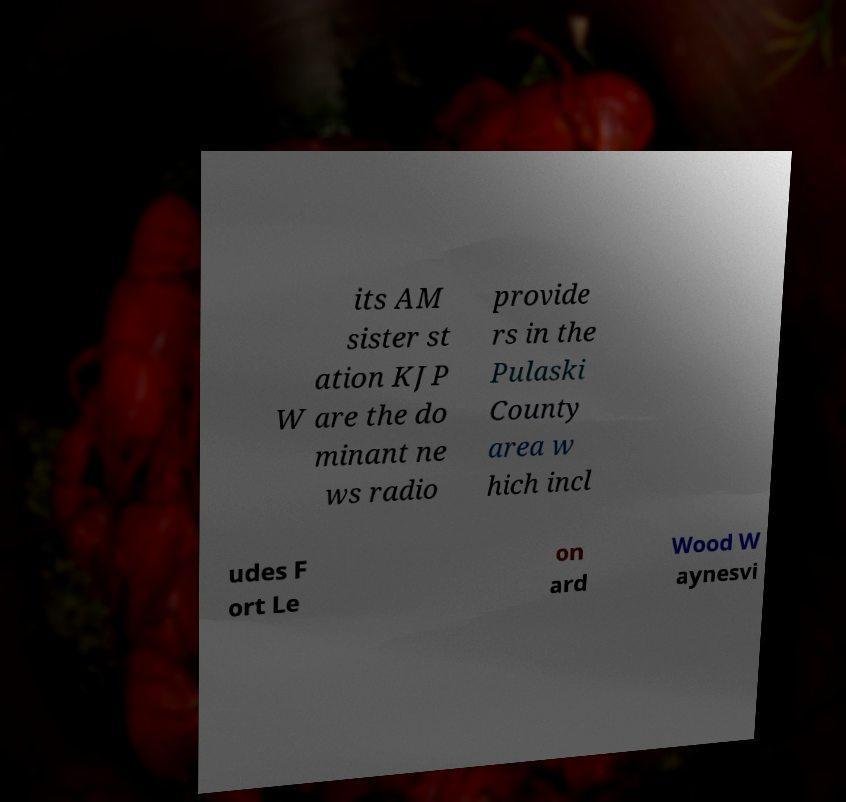For documentation purposes, I need the text within this image transcribed. Could you provide that? its AM sister st ation KJP W are the do minant ne ws radio provide rs in the Pulaski County area w hich incl udes F ort Le on ard Wood W aynesvi 